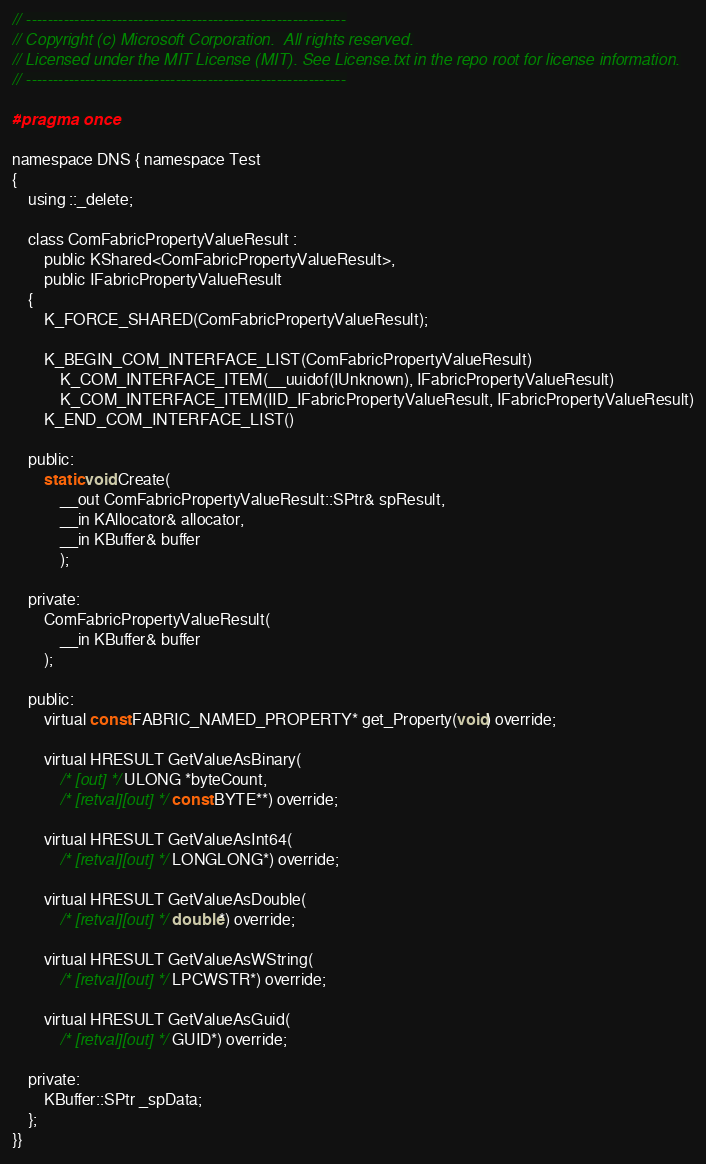<code> <loc_0><loc_0><loc_500><loc_500><_C_>// ------------------------------------------------------------
// Copyright (c) Microsoft Corporation.  All rights reserved.
// Licensed under the MIT License (MIT). See License.txt in the repo root for license information.
// ------------------------------------------------------------

#pragma once

namespace DNS { namespace Test
{
    using ::_delete;

    class ComFabricPropertyValueResult :
        public KShared<ComFabricPropertyValueResult>,
        public IFabricPropertyValueResult
    {
        K_FORCE_SHARED(ComFabricPropertyValueResult);

        K_BEGIN_COM_INTERFACE_LIST(ComFabricPropertyValueResult)
            K_COM_INTERFACE_ITEM(__uuidof(IUnknown), IFabricPropertyValueResult)
            K_COM_INTERFACE_ITEM(IID_IFabricPropertyValueResult, IFabricPropertyValueResult)
        K_END_COM_INTERFACE_LIST()

    public:
        static void Create(
            __out ComFabricPropertyValueResult::SPtr& spResult,
            __in KAllocator& allocator,
            __in KBuffer& buffer
            );

    private:
        ComFabricPropertyValueResult(
            __in KBuffer& buffer
        );

    public:
        virtual const FABRIC_NAMED_PROPERTY* get_Property(void) override;

        virtual HRESULT GetValueAsBinary(
            /* [out] */ ULONG *byteCount,
            /* [retval][out] */ const BYTE**) override;

        virtual HRESULT GetValueAsInt64(
            /* [retval][out] */ LONGLONG*) override;

        virtual HRESULT GetValueAsDouble(
            /* [retval][out] */ double*) override;

        virtual HRESULT GetValueAsWString(
            /* [retval][out] */ LPCWSTR*) override;

        virtual HRESULT GetValueAsGuid(
            /* [retval][out] */ GUID*) override;

    private:
        KBuffer::SPtr _spData;
    };
}}
</code> 